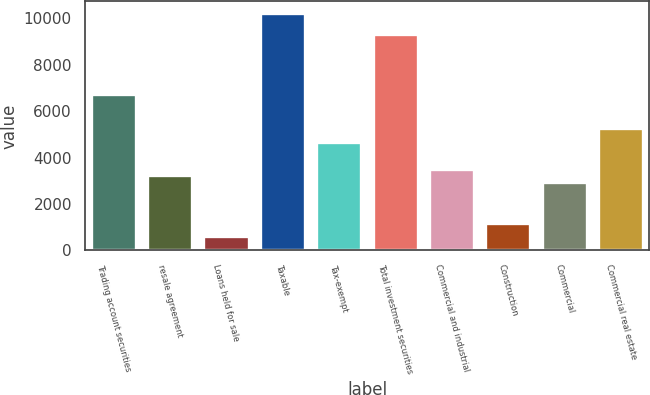<chart> <loc_0><loc_0><loc_500><loc_500><bar_chart><fcel>Trading account securities<fcel>resale agreement<fcel>Loans held for sale<fcel>Taxable<fcel>Tax-exempt<fcel>Total investment securities<fcel>Commercial and industrial<fcel>Construction<fcel>Commercial<fcel>Commercial real estate<nl><fcel>6719.4<fcel>3229.8<fcel>612.6<fcel>10209<fcel>4683.8<fcel>9336.6<fcel>3520.6<fcel>1194.2<fcel>2939<fcel>5265.4<nl></chart> 